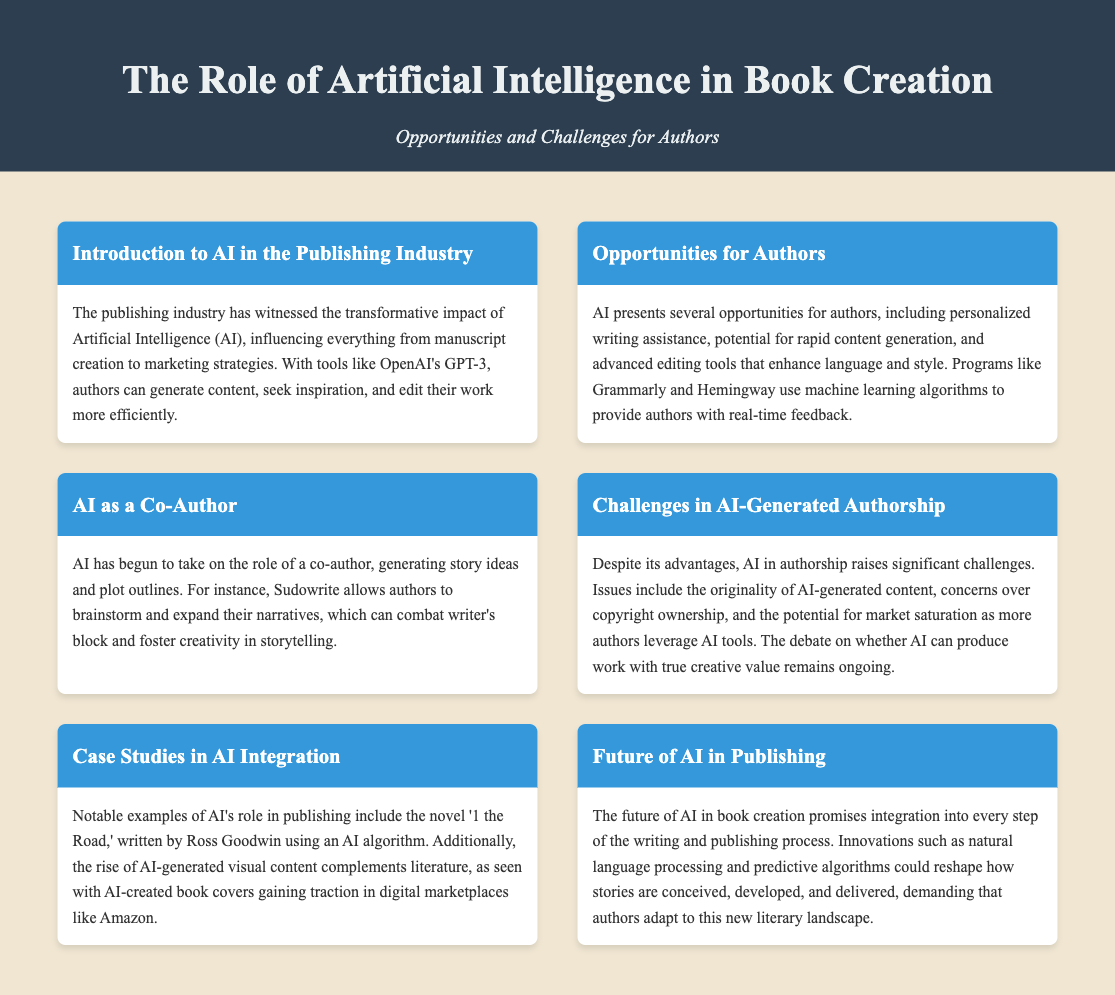What is the title of the document? The title of the document is displayed prominently in the header section.
Answer: The Role of Artificial Intelligence in Book Creation What is one opportunity for authors mentioned in the document? The document lists several opportunities for authors in the section titled "Opportunities for Authors."
Answer: Personalized writing assistance Who is an author mentioned in relation to an AI-generated novel? The document provides a specific example of an author who used AI for novel creation.
Answer: Ross Goodwin What is a challenge in AI-generated authorship mentioned? The document outlines several challenges in the section titled "Challenges in AI-Generated Authorship."
Answer: Originality of AI-generated content What technology is mentioned that helps authors with real-time feedback? The document discusses tools that provide authors with feedback in the "Opportunities for Authors" section.
Answer: Grammarly What does AI act as according to one section of the document? The document describes a role that AI takes on for authors in the related section.
Answer: Co-Author What is the potential future advancement of AI mentioned? The document addresses prospective innovations in the "Future of AI in Publishing" section.
Answer: Natural language processing What effect does AI pose on the market according to the challenges discussed? The document includes the implications for market dynamics related to AI use in authorship.
Answer: Market saturation 